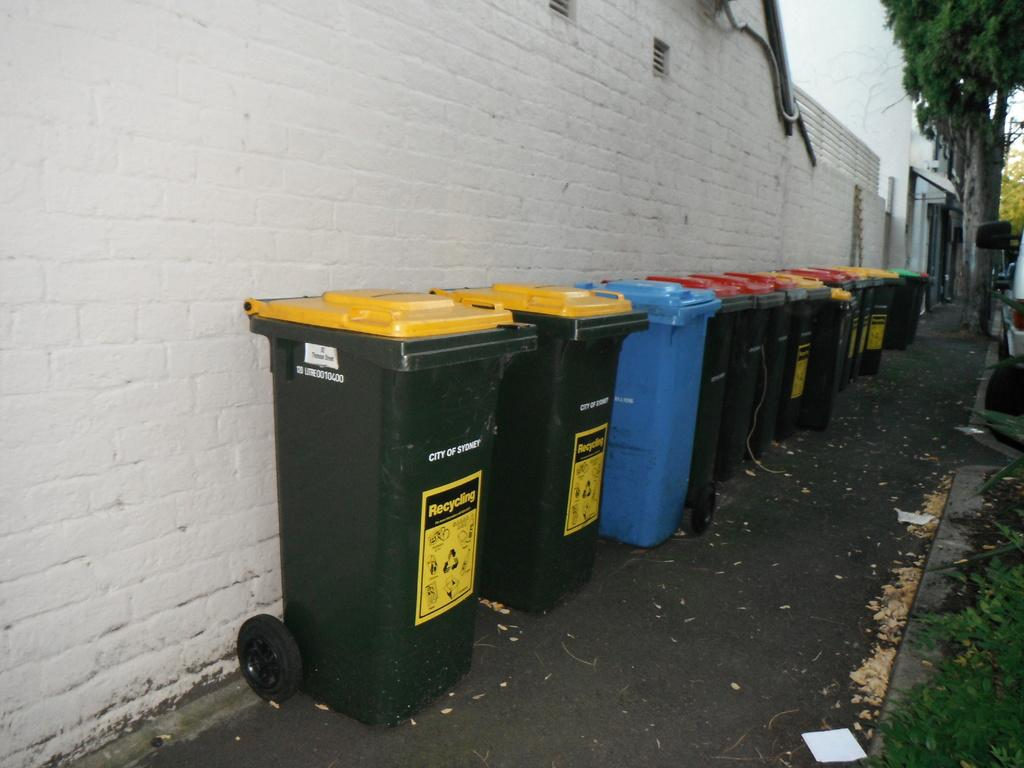<image>
Describe the image concisely. A series of recycling cans against a white wall from the City of Sydney 